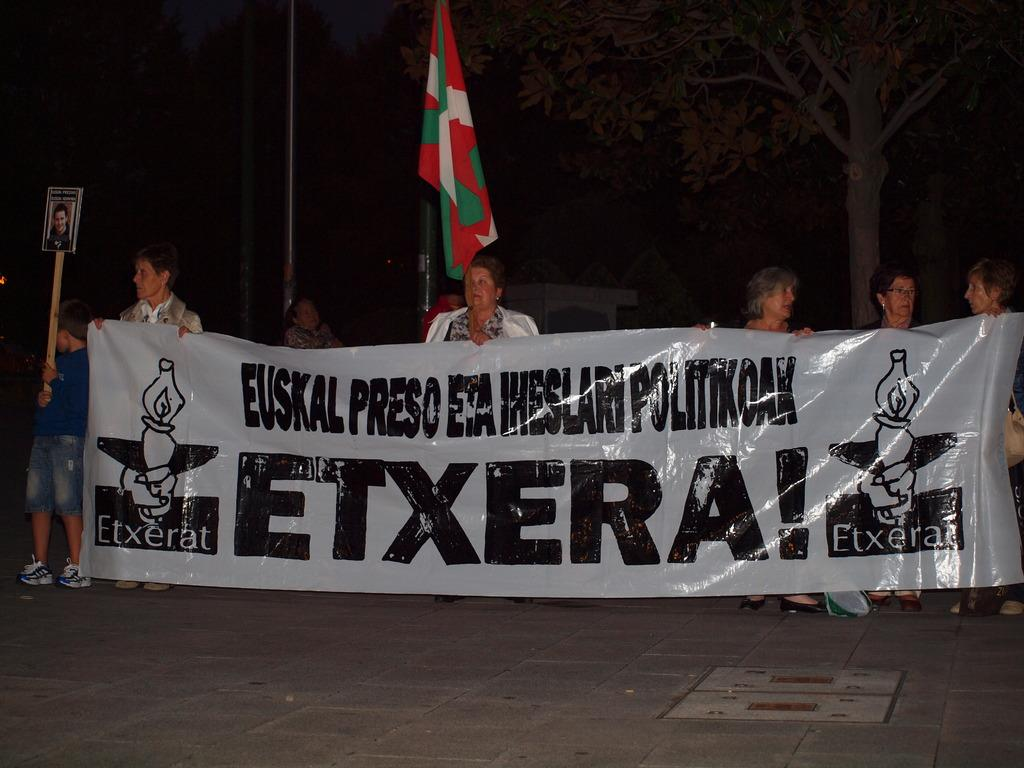How many people are in the image? There are people in the image, but the exact number is not specified. What are the people holding in their hands? The people are holding sticks and a banner. Where are the people standing in the image? They are standing on a platform. What can be seen in the background of the image? There are trees and poles in the background of the image. What type of pen is being used by the brothers in the image? There is no mention of a pen or brothers in the image, so this question cannot be answered. 